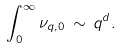<formula> <loc_0><loc_0><loc_500><loc_500>\int _ { 0 } ^ { \infty } \nu _ { q , 0 } \, \sim \, q ^ { d } .</formula> 